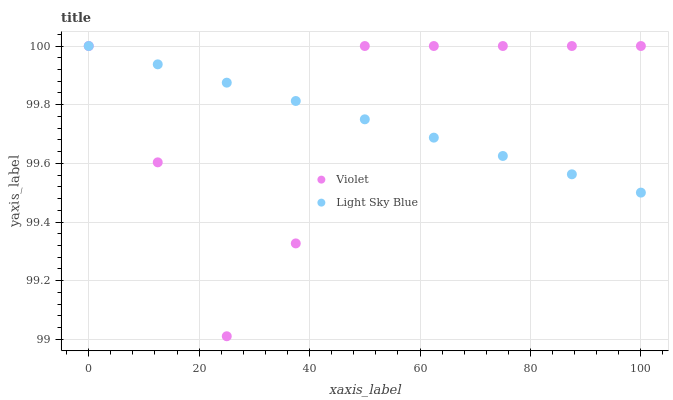Does Violet have the minimum area under the curve?
Answer yes or no. Yes. Does Light Sky Blue have the maximum area under the curve?
Answer yes or no. Yes. Does Violet have the maximum area under the curve?
Answer yes or no. No. Is Light Sky Blue the smoothest?
Answer yes or no. Yes. Is Violet the roughest?
Answer yes or no. Yes. Is Violet the smoothest?
Answer yes or no. No. Does Violet have the lowest value?
Answer yes or no. Yes. Does Violet have the highest value?
Answer yes or no. Yes. Does Violet intersect Light Sky Blue?
Answer yes or no. Yes. Is Violet less than Light Sky Blue?
Answer yes or no. No. Is Violet greater than Light Sky Blue?
Answer yes or no. No. 